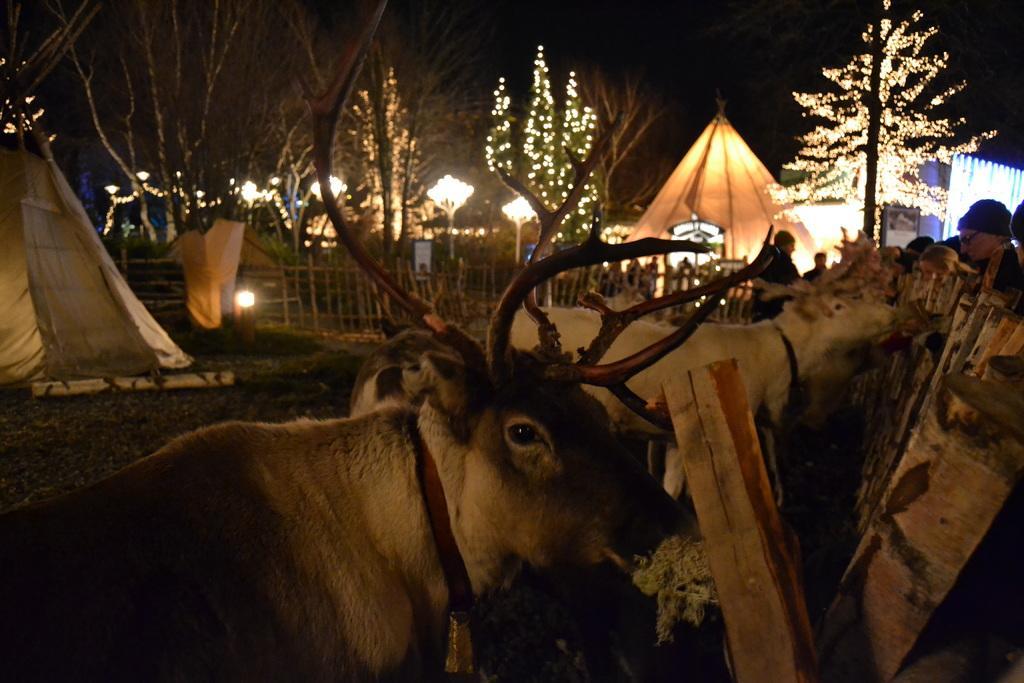Describe this image in one or two sentences. In this picture we can see the animals, tents, lights, fencing, trees, some persons, boards. At the top of the image we can see the sky. In the middle of the image we can see the ground. On the right side of the image we can see the wood logs. 